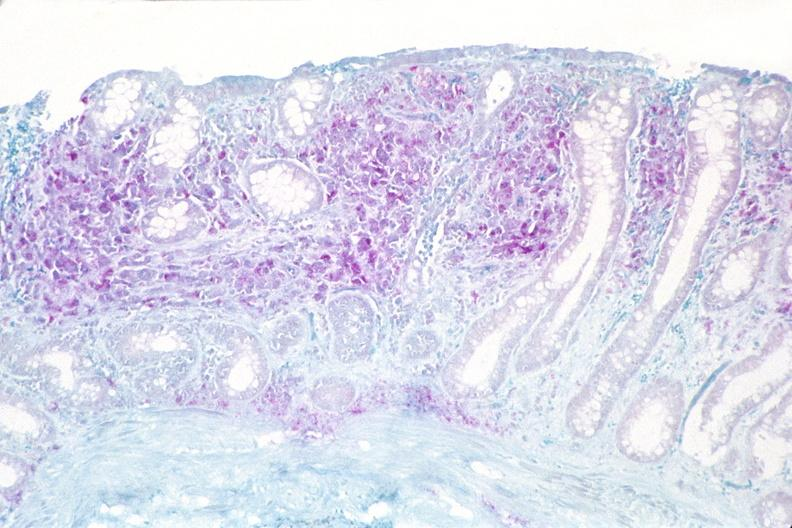s cytomegalovirus present?
Answer the question using a single word or phrase. No 